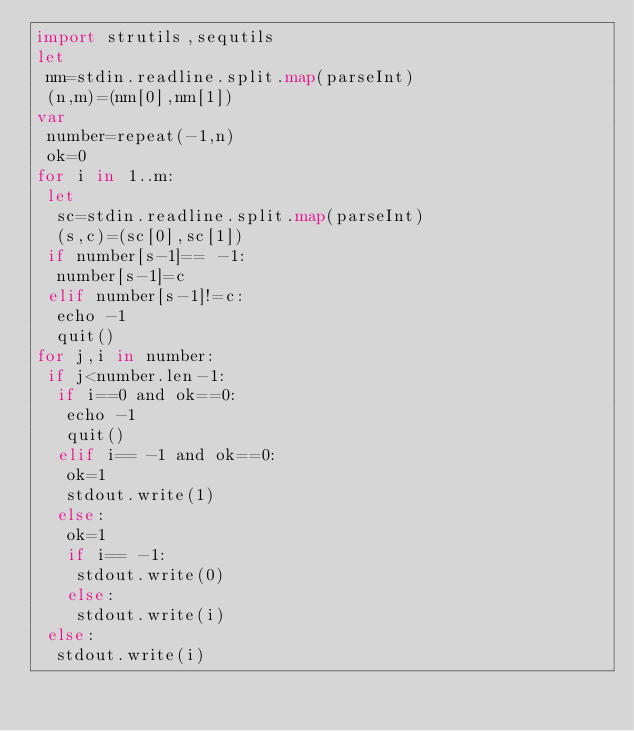Convert code to text. <code><loc_0><loc_0><loc_500><loc_500><_Nim_>import strutils,sequtils
let
 nm=stdin.readline.split.map(parseInt)
 (n,m)=(nm[0],nm[1])
var
 number=repeat(-1,n)
 ok=0
for i in 1..m:
 let
  sc=stdin.readline.split.map(parseInt)
  (s,c)=(sc[0],sc[1])
 if number[s-1]== -1:
  number[s-1]=c
 elif number[s-1]!=c:
  echo -1
  quit()
for j,i in number: 
 if j<number.len-1:
  if i==0 and ok==0:
   echo -1
   quit()
  elif i== -1 and ok==0:
   ok=1
   stdout.write(1)
  else:
   ok=1
   if i== -1:
    stdout.write(0)
   else:
    stdout.write(i)
 else:
  stdout.write(i)</code> 